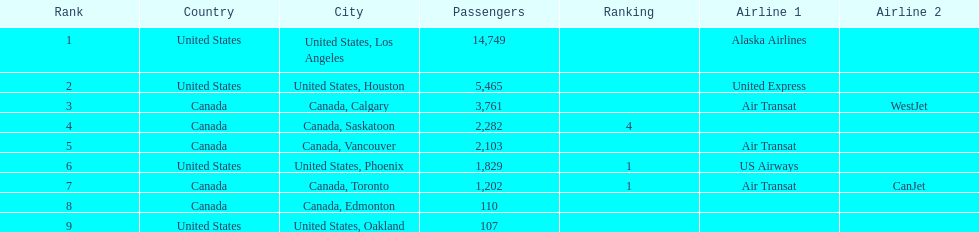Which airline carries the most passengers? Alaska Airlines. 